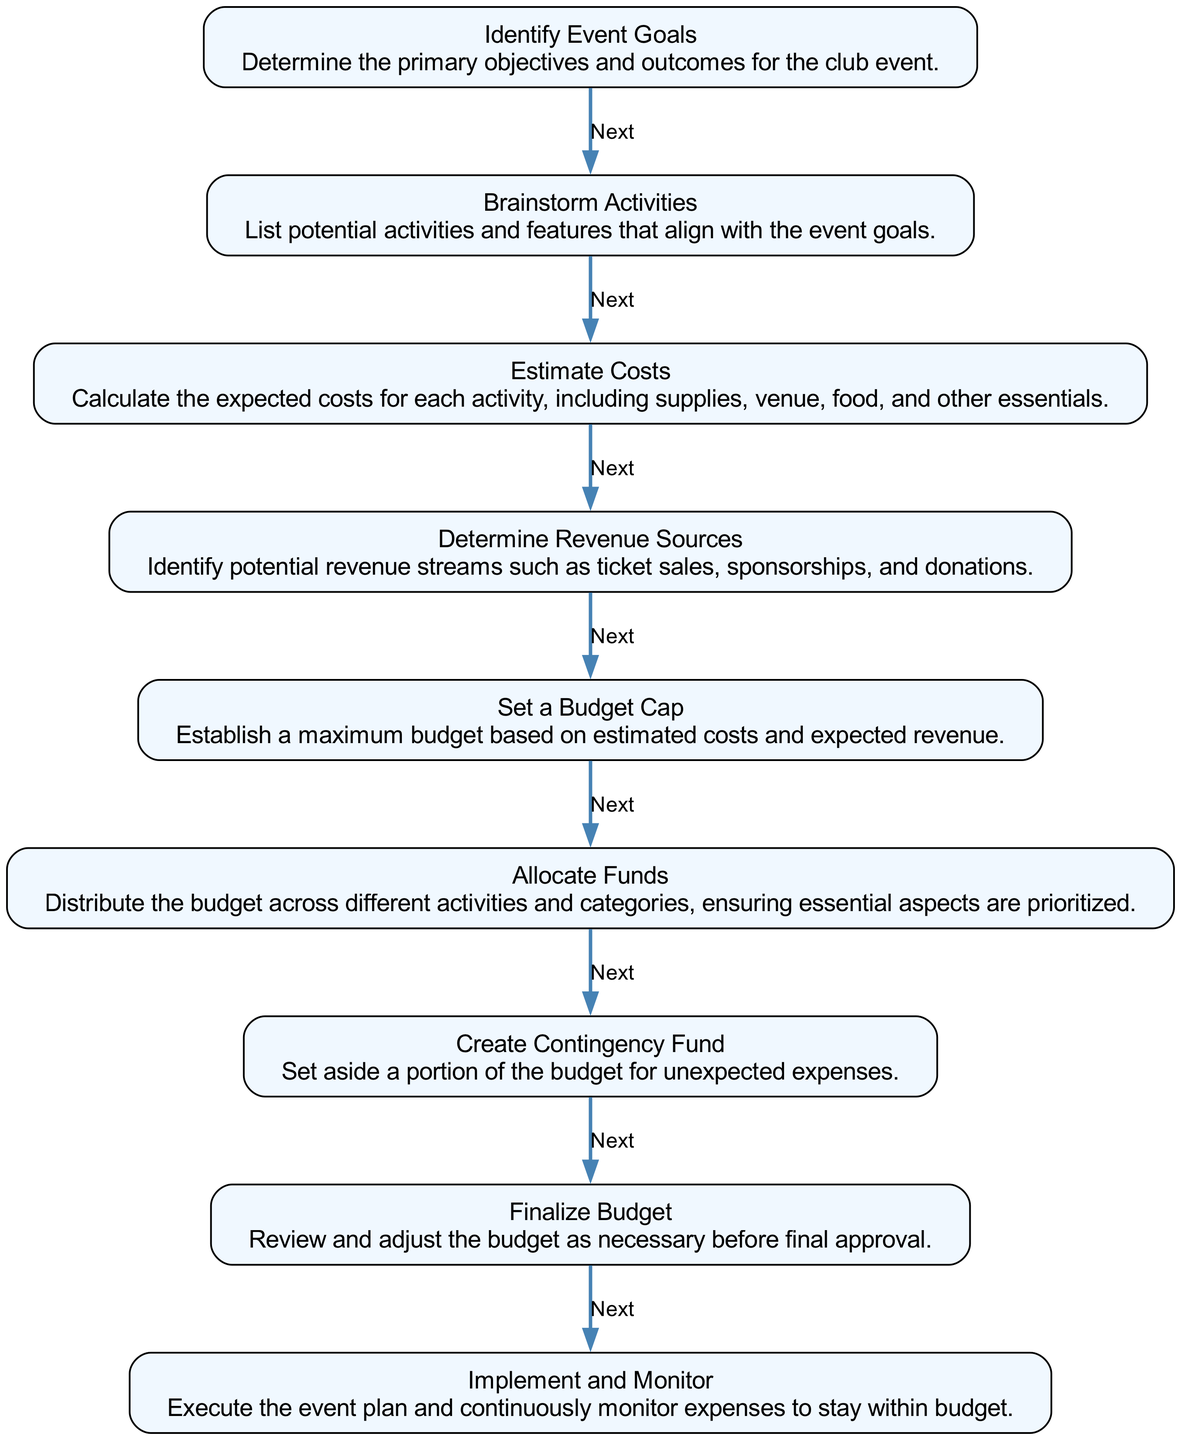What is the first step in creating a budget? The first step is "Identify Event Goals," which involves determining the primary objectives and outcomes for the club event.
Answer: Identify Event Goals How many steps are there in total? By reviewing the flow chart, there are a total of 9 steps listed in the instruction to create a budget for club events.
Answer: 9 Which step comes after "Set a Budget Cap"? The step that follows "Set a Budget Cap" is "Allocate Funds," which involves distributing the budget across different activities and ensuring priorities are addressed.
Answer: Allocate Funds What do you do after "Create Contingency Fund"? After "Create Contingency Fund," the next step is "Finalize Budget," where the budget is reviewed and adjusted as necessary before approval.
Answer: Finalize Budget What is the last step in the budget creation process? The final step in the process is "Implement and Monitor," which involves executing the event plan and monitoring expenses.
Answer: Implement and Monitor What is identified in the step before "Determine Revenue Sources"? The step right before "Determine Revenue Sources" is "Estimate Costs," which calculates expected costs for various activities associated with the event.
Answer: Estimate Costs Which step involves setting aside a portion of the budget? "Create Contingency Fund" is the step that involves setting aside a portion of the budget for unexpected expenses that may arise.
Answer: Create Contingency Fund What is the purpose of the "Set a Budget Cap" step? The purpose of "Set a Budget Cap" is to establish a maximum budget based on the estimated costs and expected revenue for the event.
Answer: Establish a maximum budget What links "Brainstorm Activities" to the next step? The link between "Brainstorm Activities" and the next step is that brainstorming aligns activities with the event goals, leading to the estimation of costs.
Answer: Estimate Costs 